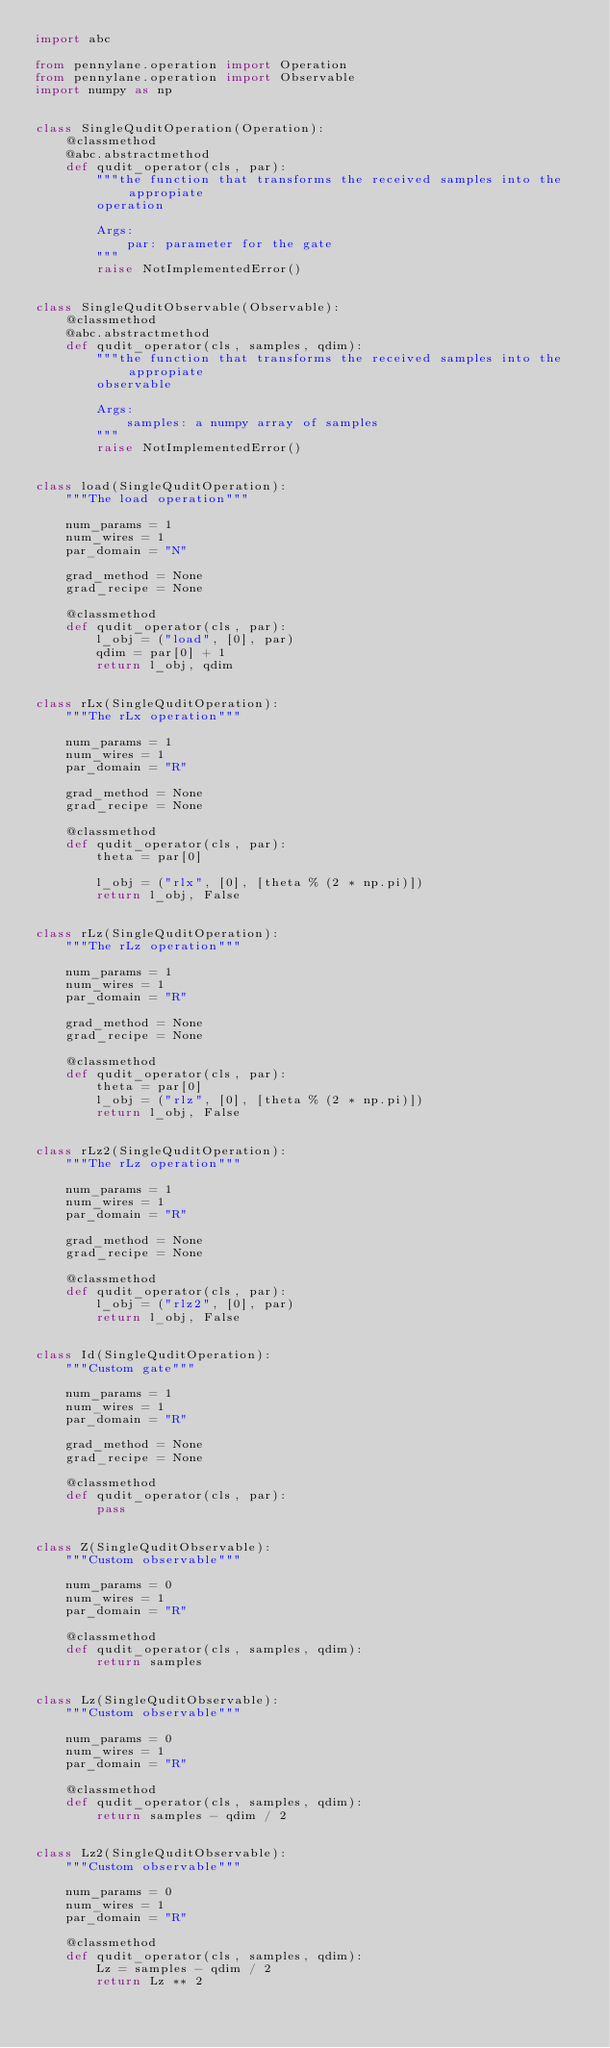Convert code to text. <code><loc_0><loc_0><loc_500><loc_500><_Python_>import abc

from pennylane.operation import Operation
from pennylane.operation import Observable
import numpy as np


class SingleQuditOperation(Operation):
    @classmethod
    @abc.abstractmethod
    def qudit_operator(cls, par):
        """the function that transforms the received samples into the appropiate
        operation

        Args:
            par: parameter for the gate
        """
        raise NotImplementedError()


class SingleQuditObservable(Observable):
    @classmethod
    @abc.abstractmethod
    def qudit_operator(cls, samples, qdim):
        """the function that transforms the received samples into the appropiate
        observable

        Args:
            samples: a numpy array of samples
        """
        raise NotImplementedError()


class load(SingleQuditOperation):
    """The load operation"""

    num_params = 1
    num_wires = 1
    par_domain = "N"

    grad_method = None
    grad_recipe = None

    @classmethod
    def qudit_operator(cls, par):
        l_obj = ("load", [0], par)
        qdim = par[0] + 1
        return l_obj, qdim


class rLx(SingleQuditOperation):
    """The rLx operation"""

    num_params = 1
    num_wires = 1
    par_domain = "R"

    grad_method = None
    grad_recipe = None

    @classmethod
    def qudit_operator(cls, par):
        theta = par[0]

        l_obj = ("rlx", [0], [theta % (2 * np.pi)])
        return l_obj, False


class rLz(SingleQuditOperation):
    """The rLz operation"""

    num_params = 1
    num_wires = 1
    par_domain = "R"

    grad_method = None
    grad_recipe = None

    @classmethod
    def qudit_operator(cls, par):
        theta = par[0]
        l_obj = ("rlz", [0], [theta % (2 * np.pi)])
        return l_obj, False


class rLz2(SingleQuditOperation):
    """The rLz operation"""

    num_params = 1
    num_wires = 1
    par_domain = "R"

    grad_method = None
    grad_recipe = None

    @classmethod
    def qudit_operator(cls, par):
        l_obj = ("rlz2", [0], par)
        return l_obj, False


class Id(SingleQuditOperation):
    """Custom gate"""

    num_params = 1
    num_wires = 1
    par_domain = "R"

    grad_method = None
    grad_recipe = None

    @classmethod
    def qudit_operator(cls, par):
        pass


class Z(SingleQuditObservable):
    """Custom observable"""

    num_params = 0
    num_wires = 1
    par_domain = "R"

    @classmethod
    def qudit_operator(cls, samples, qdim):
        return samples


class Lz(SingleQuditObservable):
    """Custom observable"""

    num_params = 0
    num_wires = 1
    par_domain = "R"

    @classmethod
    def qudit_operator(cls, samples, qdim):
        return samples - qdim / 2


class Lz2(SingleQuditObservable):
    """Custom observable"""

    num_params = 0
    num_wires = 1
    par_domain = "R"

    @classmethod
    def qudit_operator(cls, samples, qdim):
        Lz = samples - qdim / 2
        return Lz ** 2
</code> 